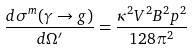Convert formula to latex. <formula><loc_0><loc_0><loc_500><loc_500>\frac { d \sigma ^ { m } ( \gamma \rightarrow g ) } { d \Omega ^ { \prime } } = \frac { \kappa ^ { 2 } V ^ { 2 } B ^ { 2 } p ^ { 2 } } { 1 2 8 \pi ^ { 2 } }</formula> 